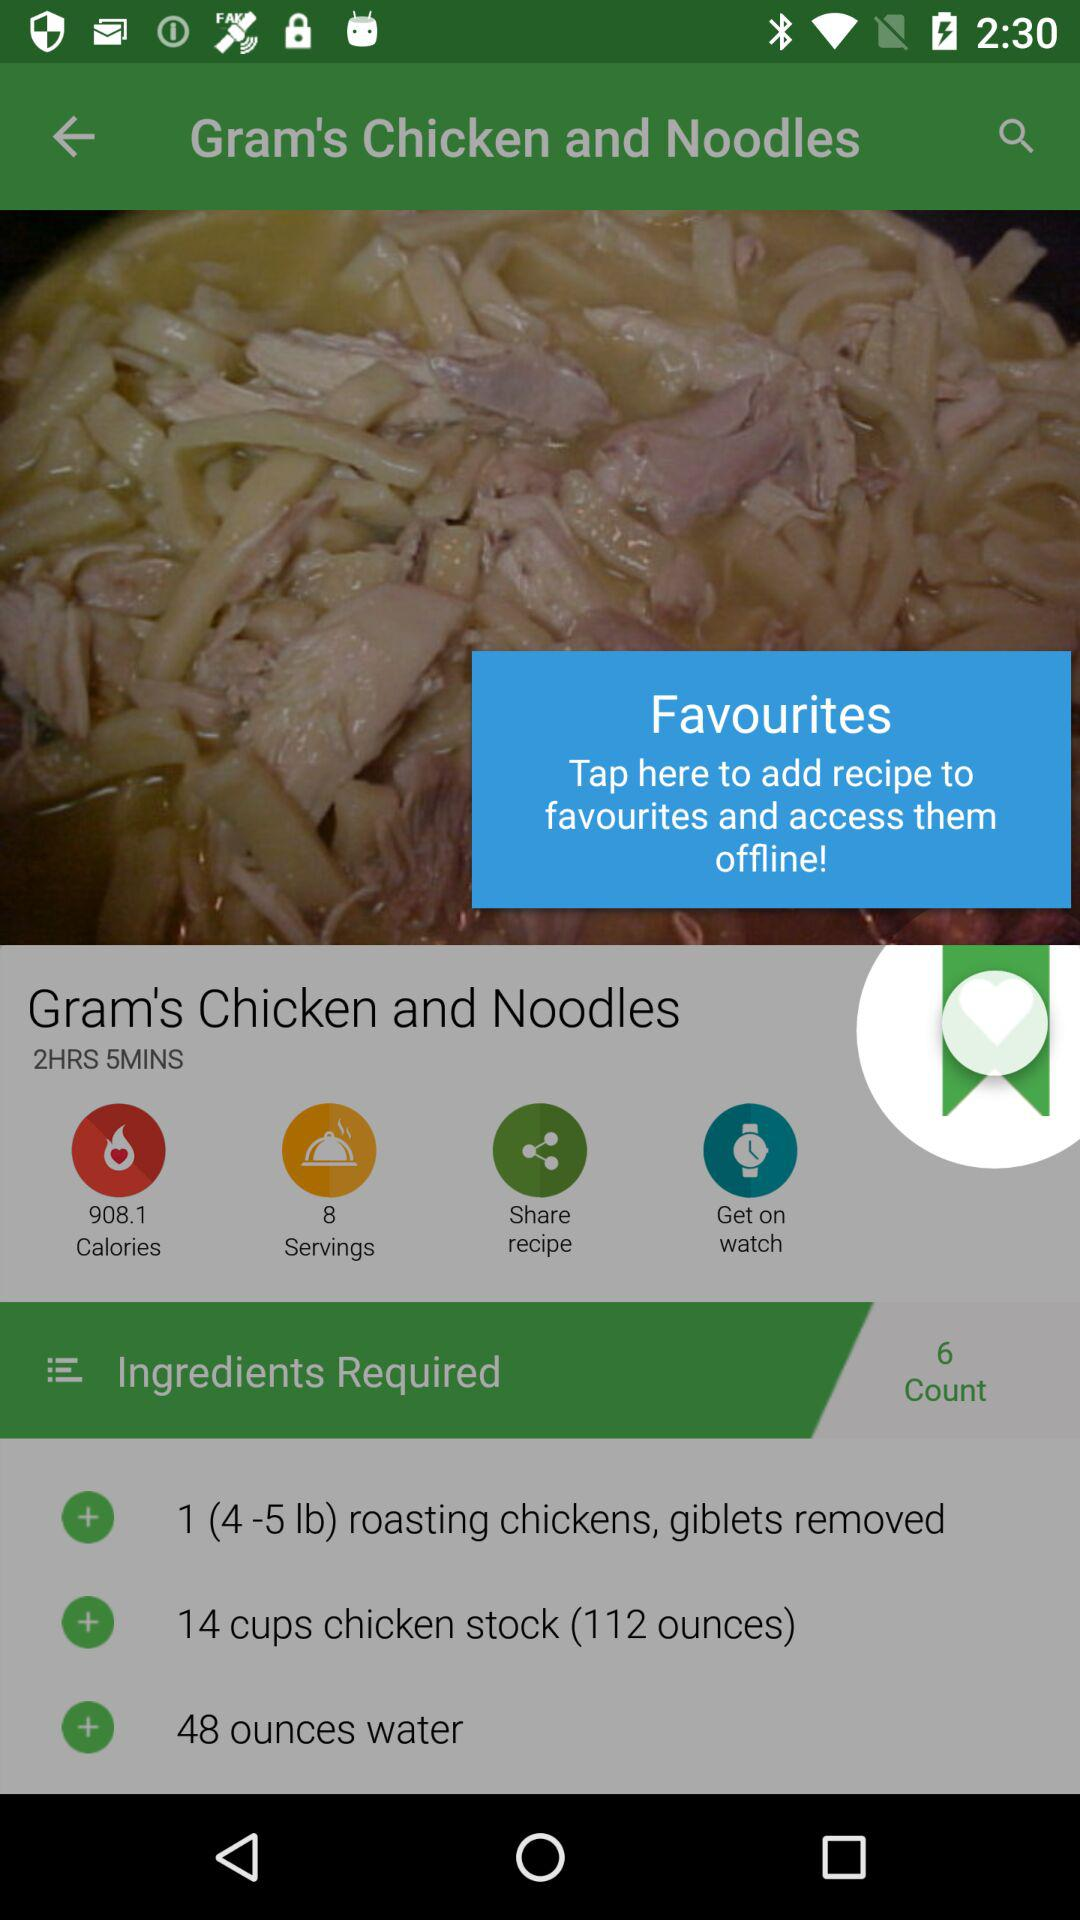How many calories are in this recipe?
Answer the question using a single word or phrase. 908.1 